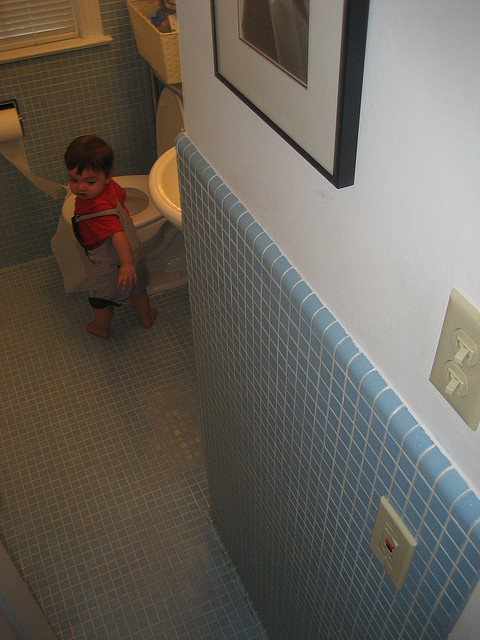<image>What animal is in the picture? There is no animal in the picture. It could be a human. What animal is in the picture? I am not sure what animal is in the picture. It can be seen humans or babies. 